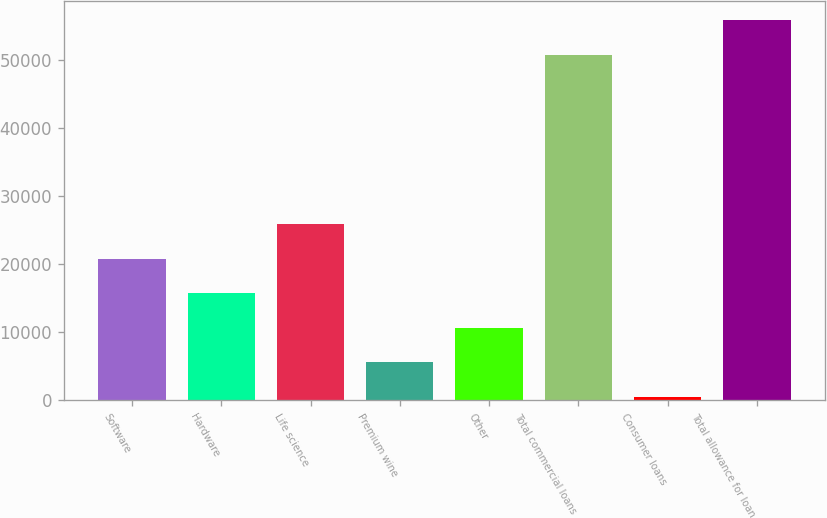Convert chart. <chart><loc_0><loc_0><loc_500><loc_500><bar_chart><fcel>Software<fcel>Hardware<fcel>Life science<fcel>Premium wine<fcel>Other<fcel>Total commercial loans<fcel>Consumer loans<fcel>Total allowance for loan<nl><fcel>20789<fcel>15714<fcel>25864<fcel>5564<fcel>10639<fcel>50750<fcel>489<fcel>55825<nl></chart> 